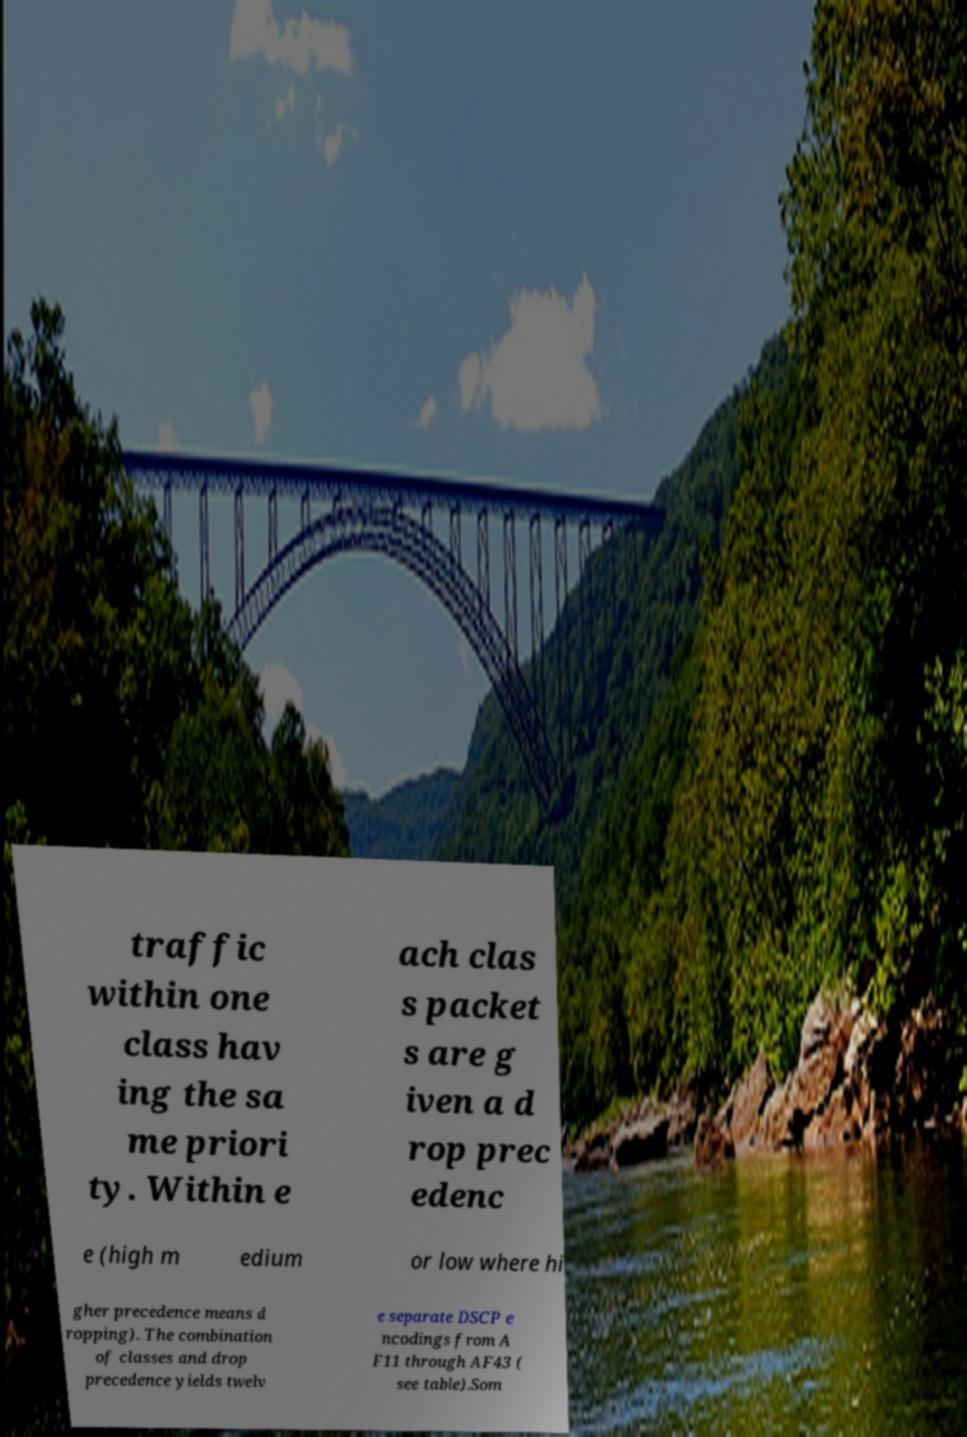Can you accurately transcribe the text from the provided image for me? traffic within one class hav ing the sa me priori ty. Within e ach clas s packet s are g iven a d rop prec edenc e (high m edium or low where hi gher precedence means d ropping). The combination of classes and drop precedence yields twelv e separate DSCP e ncodings from A F11 through AF43 ( see table).Som 